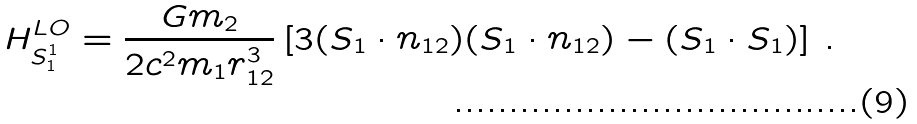Convert formula to latex. <formula><loc_0><loc_0><loc_500><loc_500>H _ { S ^ { 1 } _ { 1 } } ^ { L O } = \frac { G m _ { 2 } } { 2 c ^ { 2 } m _ { 1 } r _ { 1 2 } ^ { 3 } } \left [ 3 ( S _ { 1 } \cdot n _ { 1 2 } ) ( S _ { 1 } \cdot n _ { 1 2 } ) - ( S _ { 1 } \cdot S _ { 1 } ) \right ] \, .</formula> 